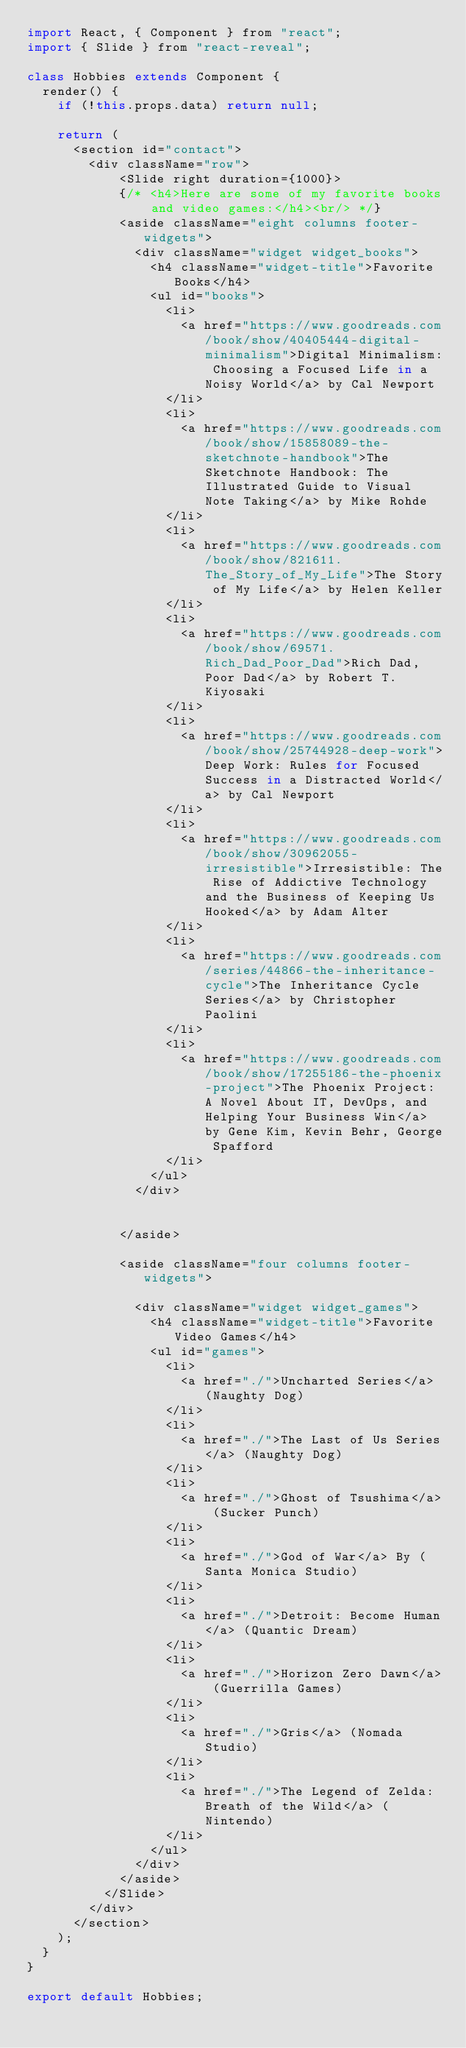Convert code to text. <code><loc_0><loc_0><loc_500><loc_500><_JavaScript_>import React, { Component } from "react";
import { Slide } from "react-reveal";

class Hobbies extends Component {
  render() {
    if (!this.props.data) return null;

    return (
      <section id="contact">
        <div className="row">
            <Slide right duration={1000}>
            {/* <h4>Here are some of my favorite books and video games:</h4><br/> */}
            <aside className="eight columns footer-widgets">
              <div className="widget widget_books">
                <h4 className="widget-title">Favorite Books</h4>
                <ul id="books">
                  <li>
                    <a href="https://www.goodreads.com/book/show/40405444-digital-minimalism">Digital Minimalism: Choosing a Focused Life in a Noisy World</a> by Cal Newport
                  </li>
                  <li>
                    <a href="https://www.goodreads.com/book/show/15858089-the-sketchnote-handbook">The Sketchnote Handbook: The Illustrated Guide to Visual Note Taking</a> by Mike Rohde
                  </li>
                  <li>
                    <a href="https://www.goodreads.com/book/show/821611.The_Story_of_My_Life">The Story of My Life</a> by Helen Keller
                  </li>
                  <li>
                    <a href="https://www.goodreads.com/book/show/69571.Rich_Dad_Poor_Dad">Rich Dad, Poor Dad</a> by Robert T. Kiyosaki
                  </li>
                  <li>
                    <a href="https://www.goodreads.com/book/show/25744928-deep-work">Deep Work: Rules for Focused Success in a Distracted World</a> by Cal Newport
                  </li>
                  <li>
                    <a href="https://www.goodreads.com/book/show/30962055-irresistible">Irresistible: The Rise of Addictive Technology and the Business of Keeping Us Hooked</a> by Adam Alter
                  </li>
                  <li>
                    <a href="https://www.goodreads.com/series/44866-the-inheritance-cycle">The Inheritance Cycle Series</a> by Christopher Paolini
                  </li>
                  <li>
                    <a href="https://www.goodreads.com/book/show/17255186-the-phoenix-project">The Phoenix Project: A Novel About IT, DevOps, and Helping Your Business Win</a> by Gene Kim, Kevin Behr, George Spafford
                  </li>
                </ul>
              </div>

              
            </aside>
            
            <aside className="four columns footer-widgets">
              
              <div className="widget widget_games">
                <h4 className="widget-title">Favorite Video Games</h4>
                <ul id="games">
                  <li>
                    <a href="./">Uncharted Series</a> (Naughty Dog)
                  </li>
                  <li>
                    <a href="./">The Last of Us Series</a> (Naughty Dog)
                  </li>
                  <li>
                    <a href="./">Ghost of Tsushima</a> (Sucker Punch)
                  </li>
                  <li>
                    <a href="./">God of War</a> By (Santa Monica Studio)
                  </li>
                  <li>
                    <a href="./">Detroit: Become Human</a> (Quantic Dream)
                  </li>
                  <li>
                    <a href="./">Horizon Zero Dawn</a> (Guerrilla Games)
                  </li>
                  <li>
                    <a href="./">Gris</a> (Nomada Studio)
                  </li>
                  <li>
                    <a href="./">The Legend of Zelda: Breath of the Wild</a> (Nintendo)
                  </li>
                </ul>
              </div>
            </aside>
          </Slide>
        </div>
      </section>
    );
  }
}

export default Hobbies;
</code> 